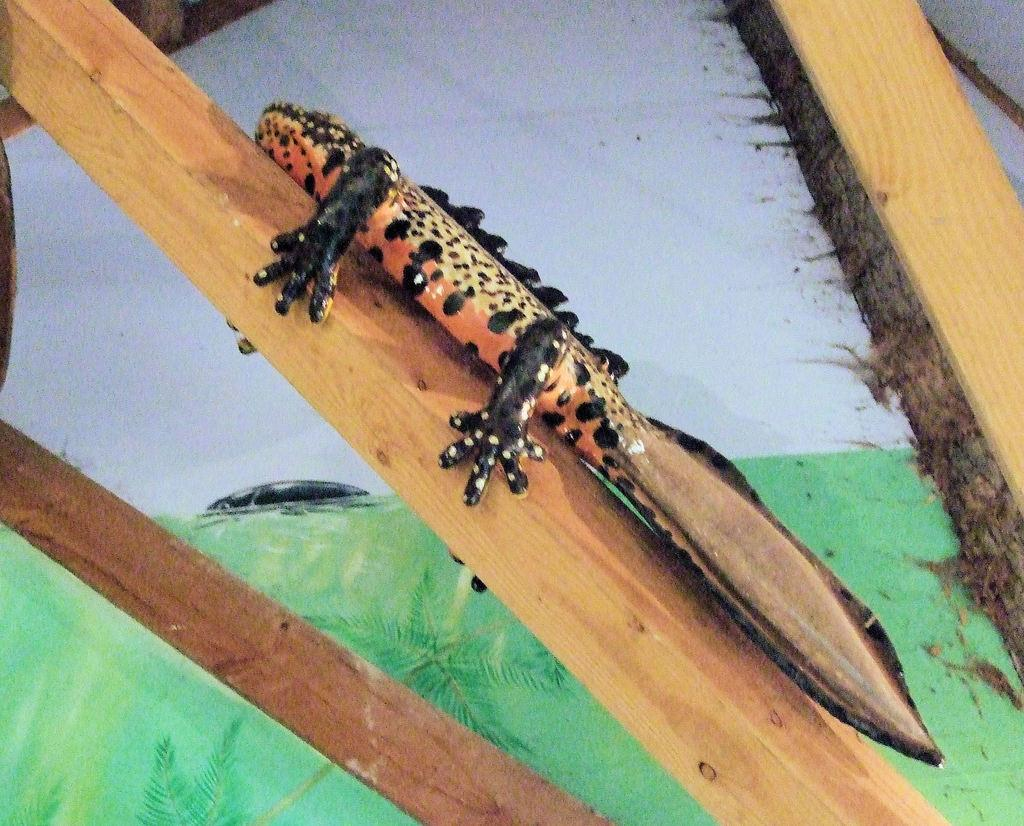What is the main object on a wooden stick in the image? There is a toy object on a wooden stick in the image. Are there any other sticks present in the image? Yes, there are sticks on either side of the toy object. What can be seen in the background of the image? The background of the image consists of greenery and drawings. Can you tell me how many pickles are hanging from the straw in the image? There is no straw or pickles present in the image. What type of friend is visible in the image? There is no friend visible in the image. 